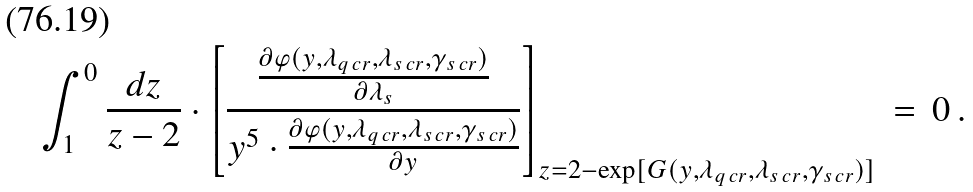<formula> <loc_0><loc_0><loc_500><loc_500>\int _ { 1 } ^ { 0 } \frac { d z } { z - 2 } \cdot \left [ \frac { \frac { \partial \varphi ( y , \lambda _ { q \, c r } , \lambda _ { s \, c r } , \gamma _ { s \, c r } ) } { \partial \lambda _ { s } } } { y ^ { 5 } \cdot \frac { \partial \varphi ( y , \lambda _ { q \, c r } , \lambda _ { s \, c r } , \gamma _ { s \, c r } ) } { \partial y } } \right ] _ { z = 2 - \exp [ G ( y , \lambda _ { q \, c r } , \lambda _ { s \, c r } , \gamma _ { s \, c r } ) ] } \, = \, 0 \, .</formula> 